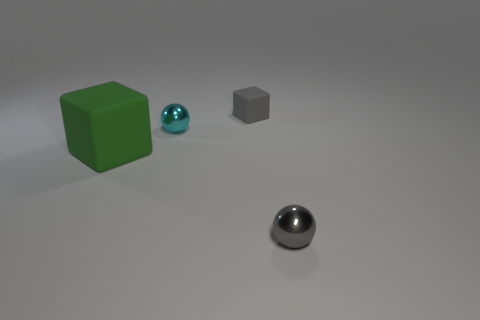Add 2 big green rubber objects. How many objects exist? 6 Add 1 large gray cubes. How many large gray cubes exist? 1 Subtract 0 brown balls. How many objects are left? 4 Subtract all large green blocks. Subtract all metal balls. How many objects are left? 1 Add 3 small gray rubber cubes. How many small gray rubber cubes are left? 4 